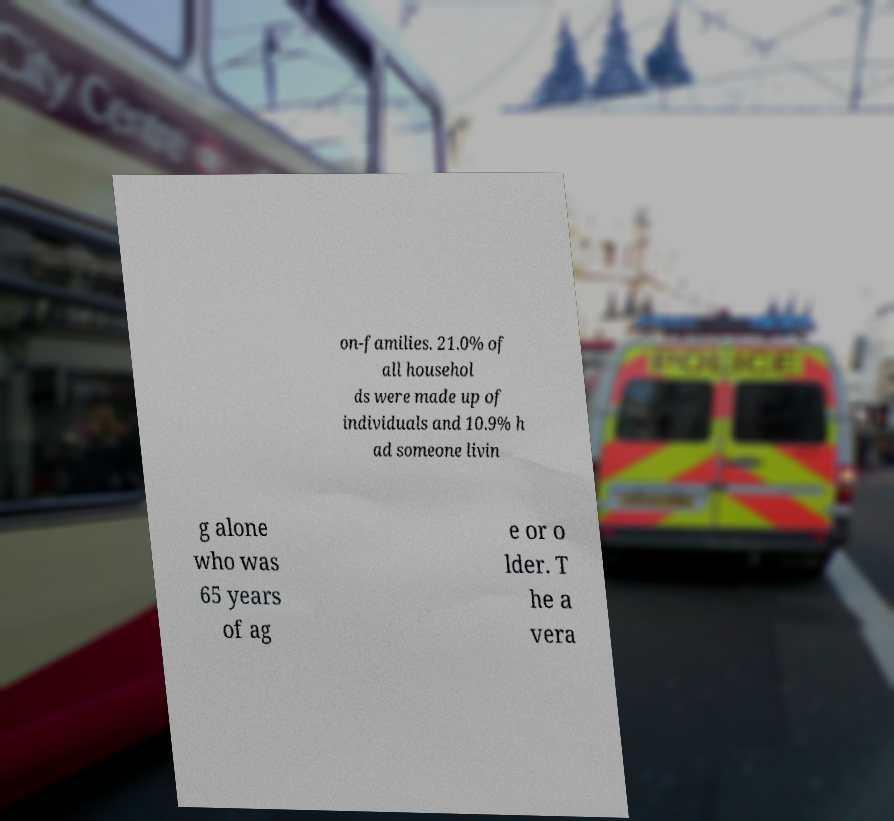Can you read and provide the text displayed in the image?This photo seems to have some interesting text. Can you extract and type it out for me? on-families. 21.0% of all househol ds were made up of individuals and 10.9% h ad someone livin g alone who was 65 years of ag e or o lder. T he a vera 